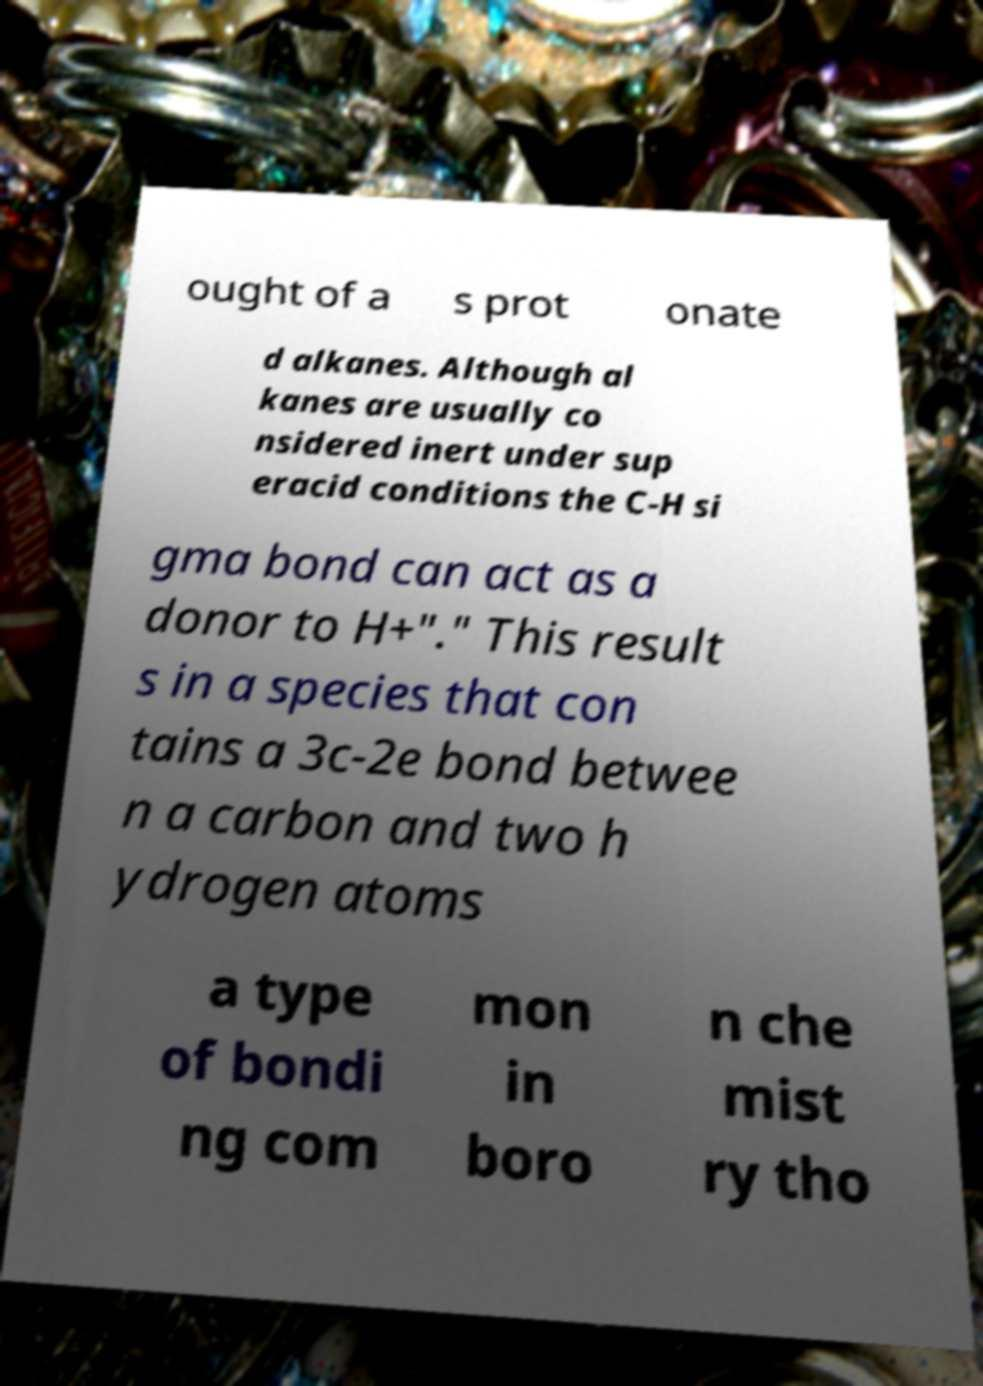Can you accurately transcribe the text from the provided image for me? ought of a s prot onate d alkanes. Although al kanes are usually co nsidered inert under sup eracid conditions the C-H si gma bond can act as a donor to H+"." This result s in a species that con tains a 3c-2e bond betwee n a carbon and two h ydrogen atoms a type of bondi ng com mon in boro n che mist ry tho 